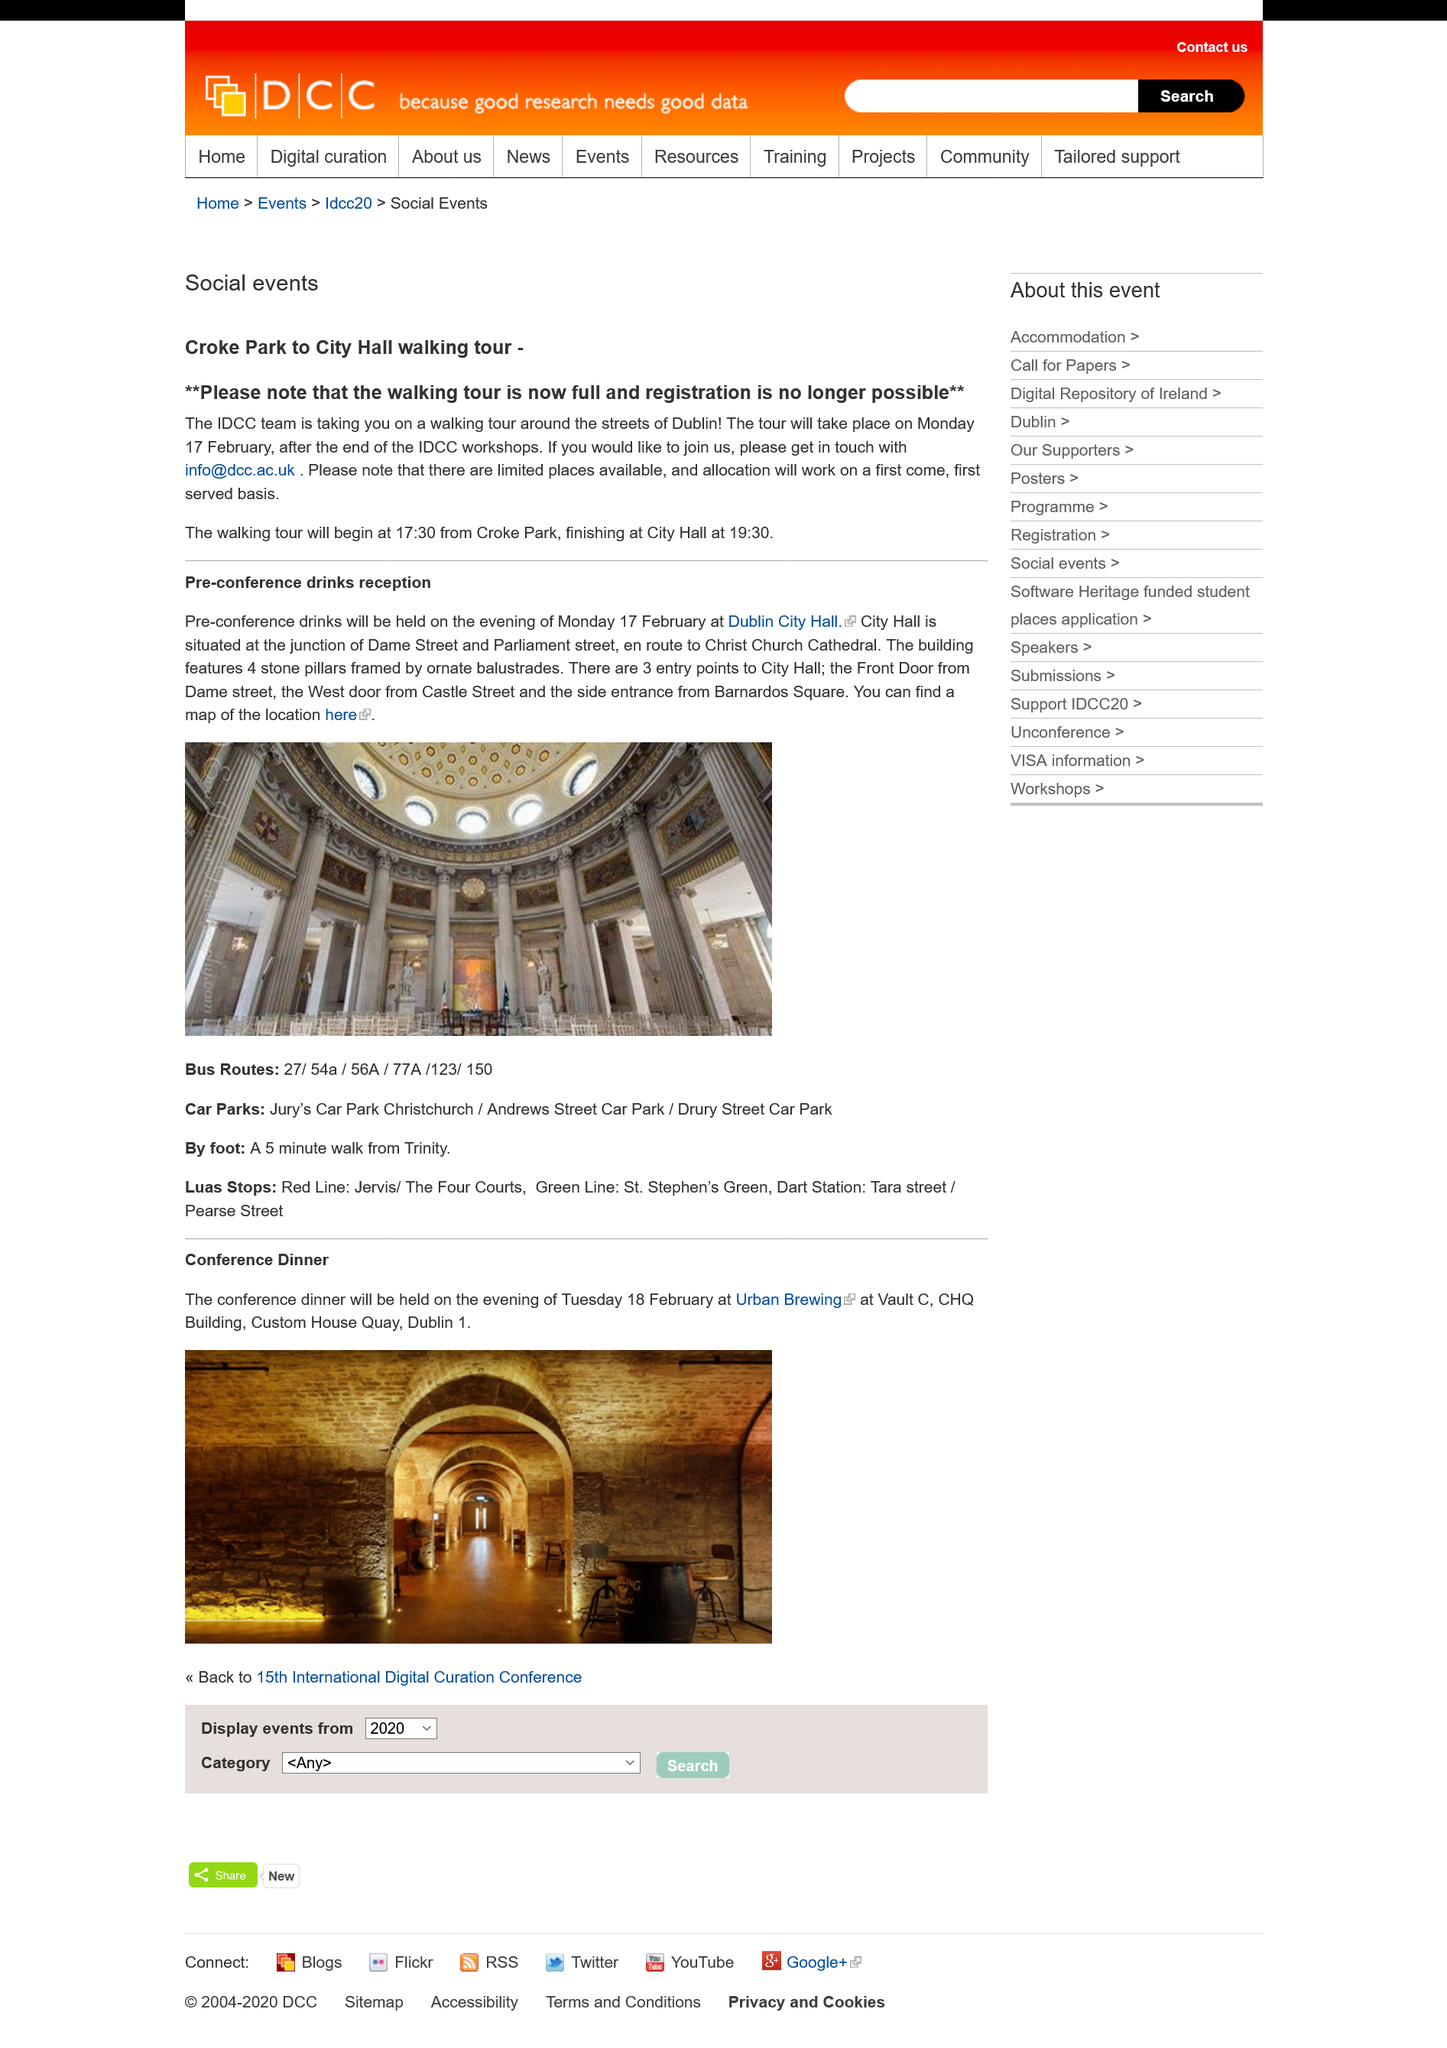Identify some key points in this picture. The walking tour is now fully booked. The walking tour will commence at 17:30. The pre-conference drinks reception will take place on the evening of Monday, February 17th at Dublin City Hall. 